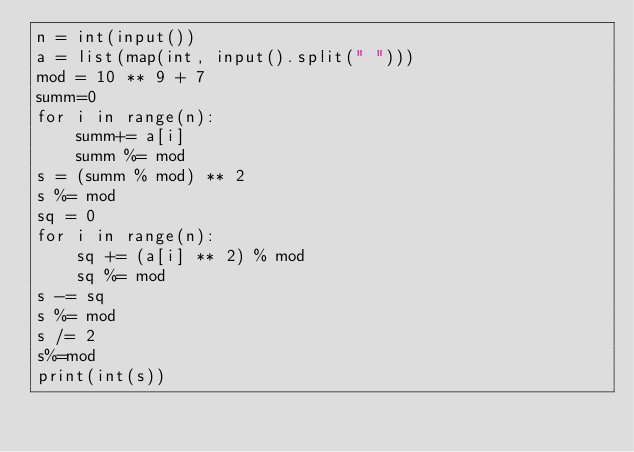Convert code to text. <code><loc_0><loc_0><loc_500><loc_500><_Python_>n = int(input())
a = list(map(int, input().split(" ")))
mod = 10 ** 9 + 7
summ=0
for i in range(n):
    summ+= a[i]
    summ %= mod
s = (summ % mod) ** 2
s %= mod
sq = 0
for i in range(n):
    sq += (a[i] ** 2) % mod
    sq %= mod
s -= sq
s %= mod
s /= 2
s%=mod
print(int(s))
</code> 